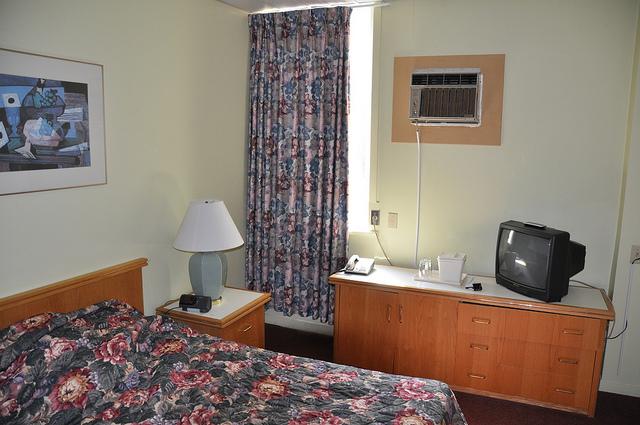Is this hotel room from this decade?
Be succinct. No. Yes it is the same color?
Give a very brief answer. Yes. What type of phone is on the table?
Write a very short answer. Landline. Is all the furniture in this room the same color?
Give a very brief answer. Yes. 